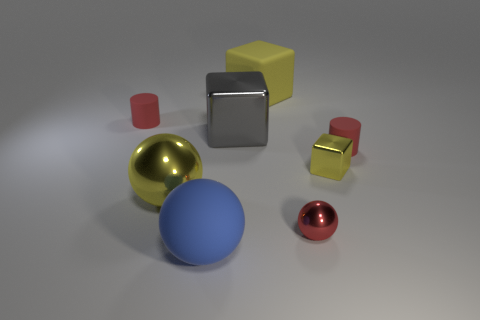What time of day does the lighting in the scene suggest? The lighting in this scene is even and diffused, with soft shadows indicating a source of light that could be artificial, such as studio lighting. It's not suggestive of a specific time of day, but rather a controlled environment like a photographer's lightbox or a computer-generated image with hypothetical lighting conditions. 